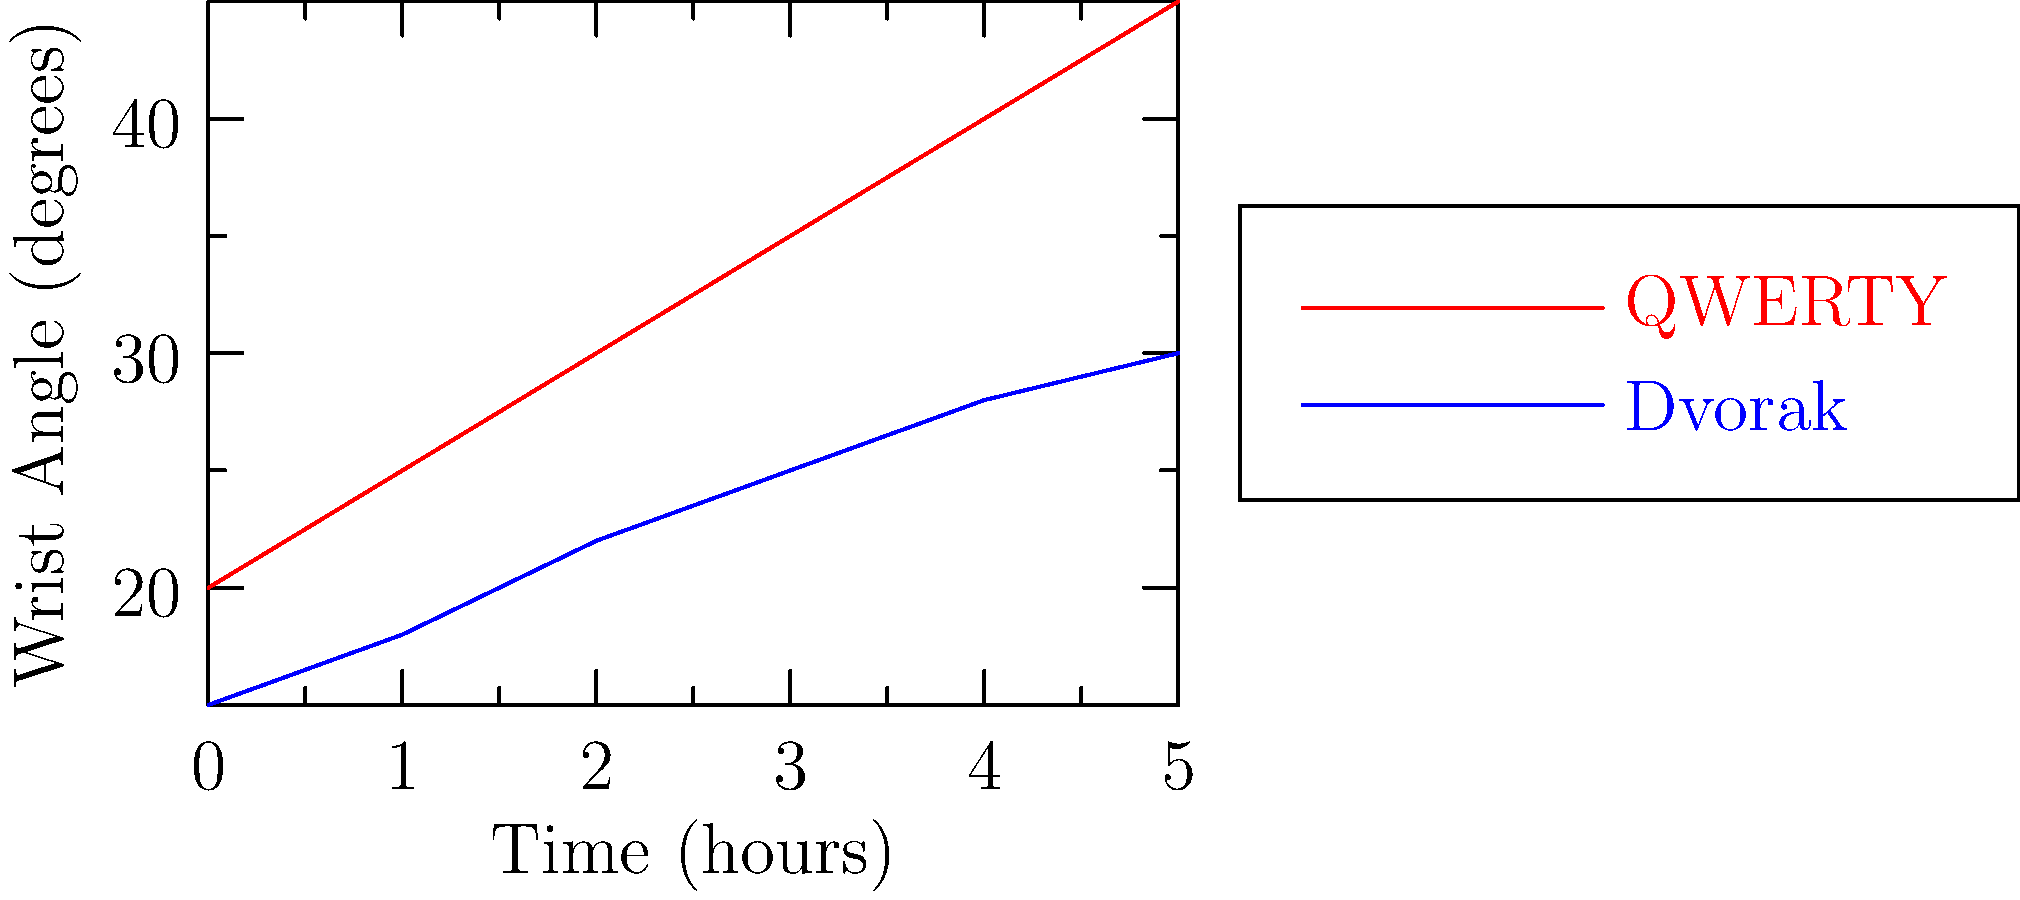Based on the line graph comparing wrist angles during typing on QWERTY and Dvorak keyboard layouts over time, which layout appears to be more ergonomic for long-term use, and how might this impact the implementation of keyboard standards in an IT project for an online gambling platform? To answer this question, we need to analyze the graph and consider its implications for IT project management in the context of online gambling:

1. Graph analysis:
   - The red line represents the QWERTY layout, while the blue line represents the Dvorak layout.
   - Both lines show an increase in wrist angle over time, indicating potential strain.
   - The QWERTY layout shows a steeper increase, reaching higher angles (45° at 5 hours) compared to Dvorak (30° at 5 hours).

2. Ergonomic implications:
   - Lower wrist angles are generally considered more ergonomic, as they reduce strain and the risk of repetitive stress injuries.
   - The Dvorak layout consistently shows lower wrist angles over time, suggesting it is more ergonomic for long-term use.

3. IT project management considerations:
   - As a project manager, you need to balance ergonomics with practicality and user adoption.
   - Implementing a Dvorak layout could potentially reduce employee health issues and increase productivity in the long run.
   - However, most users are familiar with QWERTY, and switching to Dvorak might require a learning curve and initial productivity drop.

4. Online gambling platform context:
   - In the online gambling industry, regulatory compliance is crucial.
   - Some jurisdictions might have specific ergonomic requirements for employee workstations.
   - Implementing more ergonomic keyboards could be seen as a proactive measure to ensure employee well-being and potentially avoid future legal issues.

5. Cost-benefit analysis:
   - Consider the costs of implementing new keyboard layouts (hardware, training) versus potential long-term benefits (reduced health issues, increased productivity, regulatory compliance).

6. Phased approach:
   - A possible solution could be to implement Dvorak keyboards gradually, starting with employees who spend the most time typing or those who already experience wrist strain.

Based on this analysis, the Dvorak layout appears more ergonomic for long-term use. However, the decision to implement it in an IT project for an online gambling platform would need to balance ergonomic benefits with practical considerations, user adoption, and regulatory compliance.
Answer: Dvorak; requires balanced implementation considering ergonomics, user adoption, and regulatory compliance. 